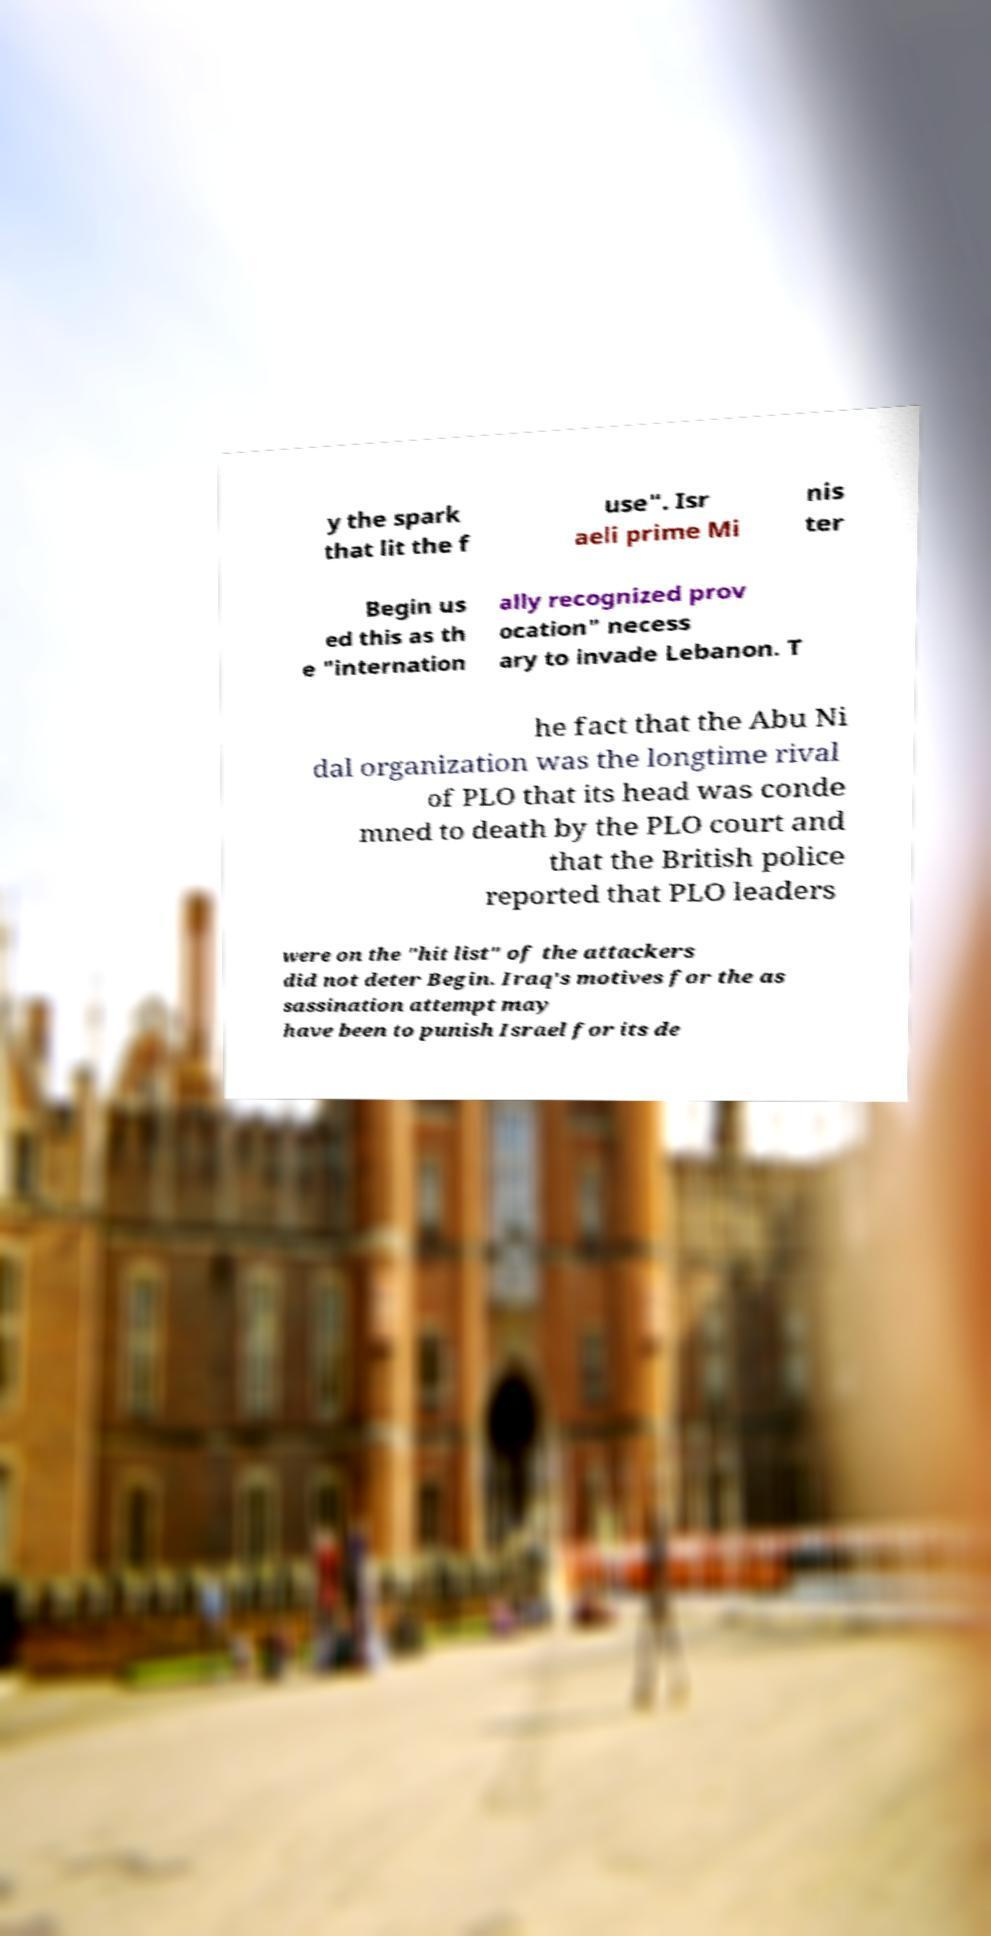Could you extract and type out the text from this image? y the spark that lit the f use". Isr aeli prime Mi nis ter Begin us ed this as th e "internation ally recognized prov ocation" necess ary to invade Lebanon. T he fact that the Abu Ni dal organization was the longtime rival of PLO that its head was conde mned to death by the PLO court and that the British police reported that PLO leaders were on the "hit list" of the attackers did not deter Begin. Iraq's motives for the as sassination attempt may have been to punish Israel for its de 